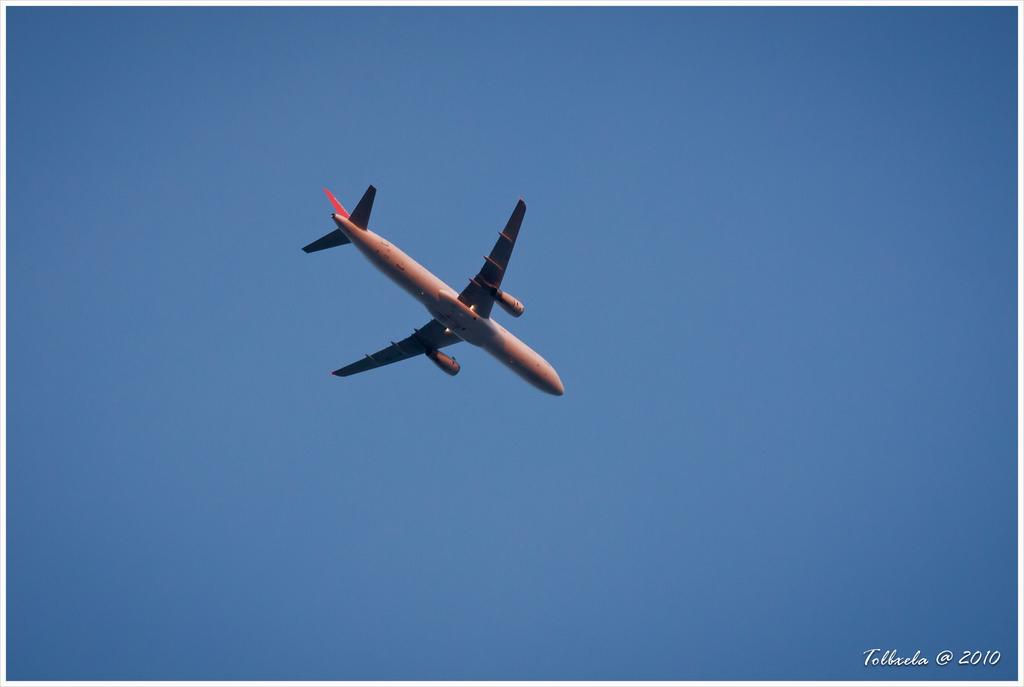What is the main subject of the image? The main subject of the image is an airplane. What is the airplane doing in the image? The airplane is flying in the sky. What color is the background of the image? The background of the image appears blue. Is there any additional information or marking on the image? Yes, there is a watermark on the image. What type of payment method is accepted for the selection of blades in the image? There is no payment method, selection of blades, or any indication of a transaction in the image; it simply features an airplane flying in the sky. 